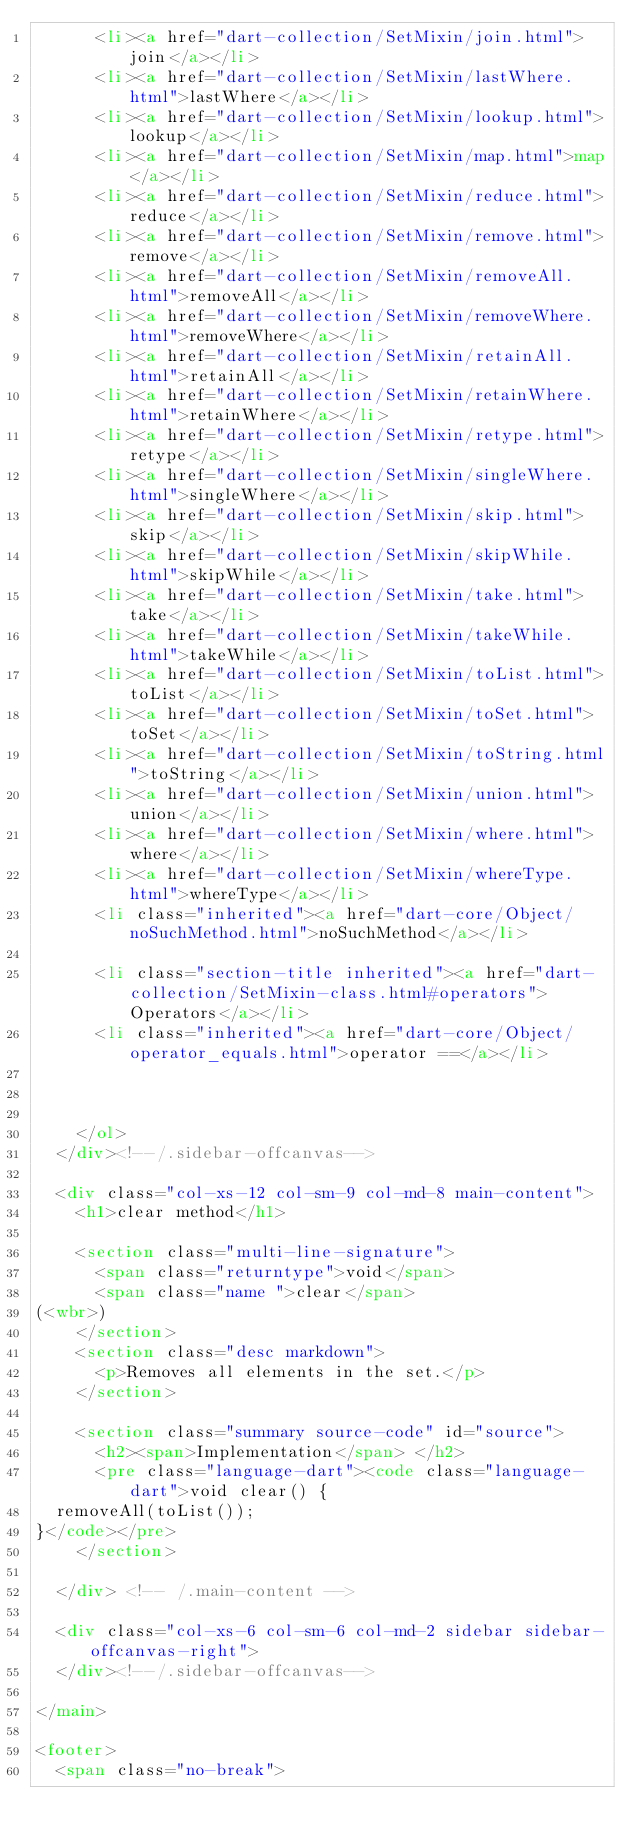<code> <loc_0><loc_0><loc_500><loc_500><_HTML_>      <li><a href="dart-collection/SetMixin/join.html">join</a></li>
      <li><a href="dart-collection/SetMixin/lastWhere.html">lastWhere</a></li>
      <li><a href="dart-collection/SetMixin/lookup.html">lookup</a></li>
      <li><a href="dart-collection/SetMixin/map.html">map</a></li>
      <li><a href="dart-collection/SetMixin/reduce.html">reduce</a></li>
      <li><a href="dart-collection/SetMixin/remove.html">remove</a></li>
      <li><a href="dart-collection/SetMixin/removeAll.html">removeAll</a></li>
      <li><a href="dart-collection/SetMixin/removeWhere.html">removeWhere</a></li>
      <li><a href="dart-collection/SetMixin/retainAll.html">retainAll</a></li>
      <li><a href="dart-collection/SetMixin/retainWhere.html">retainWhere</a></li>
      <li><a href="dart-collection/SetMixin/retype.html">retype</a></li>
      <li><a href="dart-collection/SetMixin/singleWhere.html">singleWhere</a></li>
      <li><a href="dart-collection/SetMixin/skip.html">skip</a></li>
      <li><a href="dart-collection/SetMixin/skipWhile.html">skipWhile</a></li>
      <li><a href="dart-collection/SetMixin/take.html">take</a></li>
      <li><a href="dart-collection/SetMixin/takeWhile.html">takeWhile</a></li>
      <li><a href="dart-collection/SetMixin/toList.html">toList</a></li>
      <li><a href="dart-collection/SetMixin/toSet.html">toSet</a></li>
      <li><a href="dart-collection/SetMixin/toString.html">toString</a></li>
      <li><a href="dart-collection/SetMixin/union.html">union</a></li>
      <li><a href="dart-collection/SetMixin/where.html">where</a></li>
      <li><a href="dart-collection/SetMixin/whereType.html">whereType</a></li>
      <li class="inherited"><a href="dart-core/Object/noSuchMethod.html">noSuchMethod</a></li>
    
      <li class="section-title inherited"><a href="dart-collection/SetMixin-class.html#operators">Operators</a></li>
      <li class="inherited"><a href="dart-core/Object/operator_equals.html">operator ==</a></li>
    
    
    
    </ol>
  </div><!--/.sidebar-offcanvas-->

  <div class="col-xs-12 col-sm-9 col-md-8 main-content">
    <h1>clear method</h1>

    <section class="multi-line-signature">
      <span class="returntype">void</span>
      <span class="name ">clear</span>
(<wbr>)
    </section>
    <section class="desc markdown">
      <p>Removes all elements in the set.</p>
    </section>
    
    <section class="summary source-code" id="source">
      <h2><span>Implementation</span> </h2>
      <pre class="language-dart"><code class="language-dart">void clear() {
  removeAll(toList());
}</code></pre>
    </section>

  </div> <!-- /.main-content -->

  <div class="col-xs-6 col-sm-6 col-md-2 sidebar sidebar-offcanvas-right">
  </div><!--/.sidebar-offcanvas-->

</main>

<footer>
  <span class="no-break"></code> 